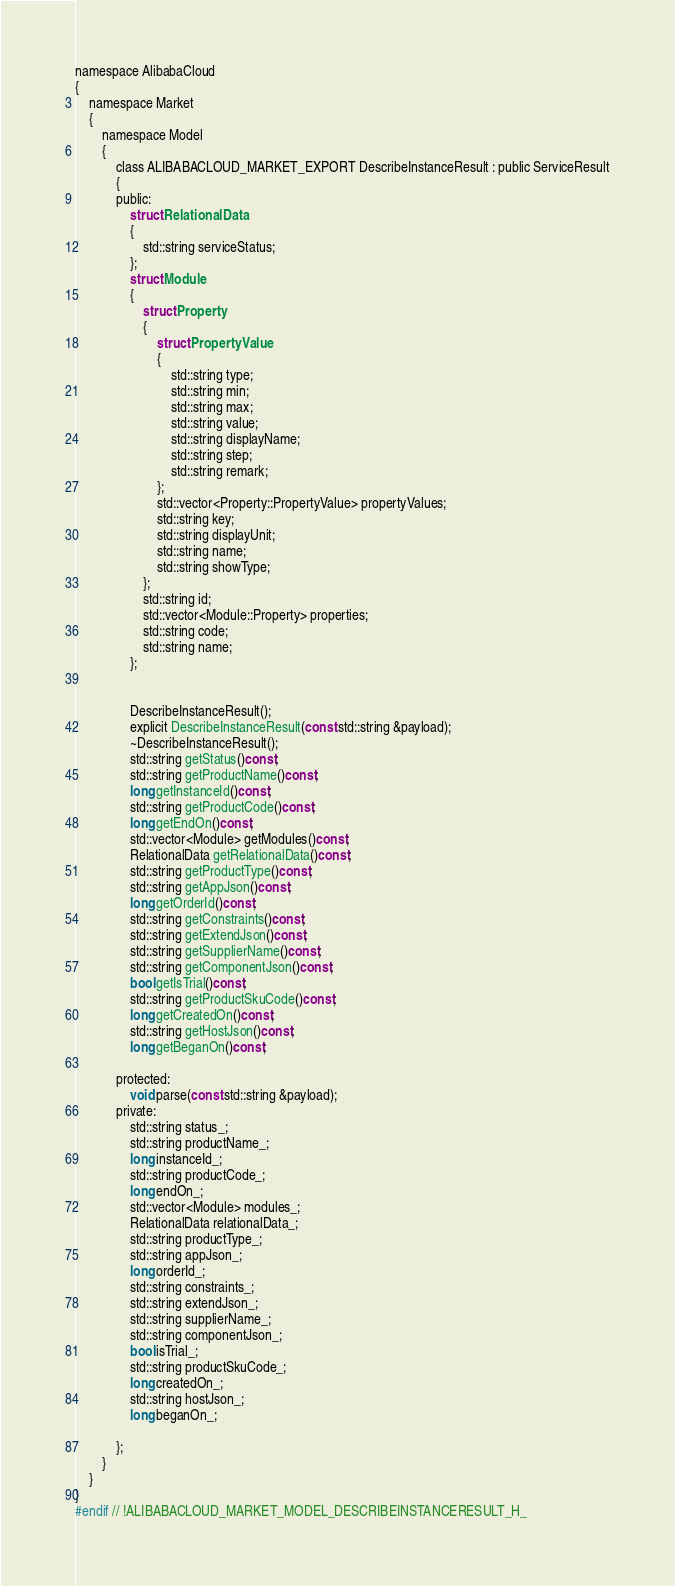<code> <loc_0><loc_0><loc_500><loc_500><_C_>namespace AlibabaCloud
{
	namespace Market
	{
		namespace Model
		{
			class ALIBABACLOUD_MARKET_EXPORT DescribeInstanceResult : public ServiceResult
			{
			public:
				struct RelationalData
				{
					std::string serviceStatus;
				};
				struct Module
				{
					struct Property
					{
						struct PropertyValue
						{
							std::string type;
							std::string min;
							std::string max;
							std::string value;
							std::string displayName;
							std::string step;
							std::string remark;
						};
						std::vector<Property::PropertyValue> propertyValues;
						std::string key;
						std::string displayUnit;
						std::string name;
						std::string showType;
					};
					std::string id;
					std::vector<Module::Property> properties;
					std::string code;
					std::string name;
				};


				DescribeInstanceResult();
				explicit DescribeInstanceResult(const std::string &payload);
				~DescribeInstanceResult();
				std::string getStatus()const;
				std::string getProductName()const;
				long getInstanceId()const;
				std::string getProductCode()const;
				long getEndOn()const;
				std::vector<Module> getModules()const;
				RelationalData getRelationalData()const;
				std::string getProductType()const;
				std::string getAppJson()const;
				long getOrderId()const;
				std::string getConstraints()const;
				std::string getExtendJson()const;
				std::string getSupplierName()const;
				std::string getComponentJson()const;
				bool getIsTrial()const;
				std::string getProductSkuCode()const;
				long getCreatedOn()const;
				std::string getHostJson()const;
				long getBeganOn()const;

			protected:
				void parse(const std::string &payload);
			private:
				std::string status_;
				std::string productName_;
				long instanceId_;
				std::string productCode_;
				long endOn_;
				std::vector<Module> modules_;
				RelationalData relationalData_;
				std::string productType_;
				std::string appJson_;
				long orderId_;
				std::string constraints_;
				std::string extendJson_;
				std::string supplierName_;
				std::string componentJson_;
				bool isTrial_;
				std::string productSkuCode_;
				long createdOn_;
				std::string hostJson_;
				long beganOn_;

			};
		}
	}
}
#endif // !ALIBABACLOUD_MARKET_MODEL_DESCRIBEINSTANCERESULT_H_</code> 